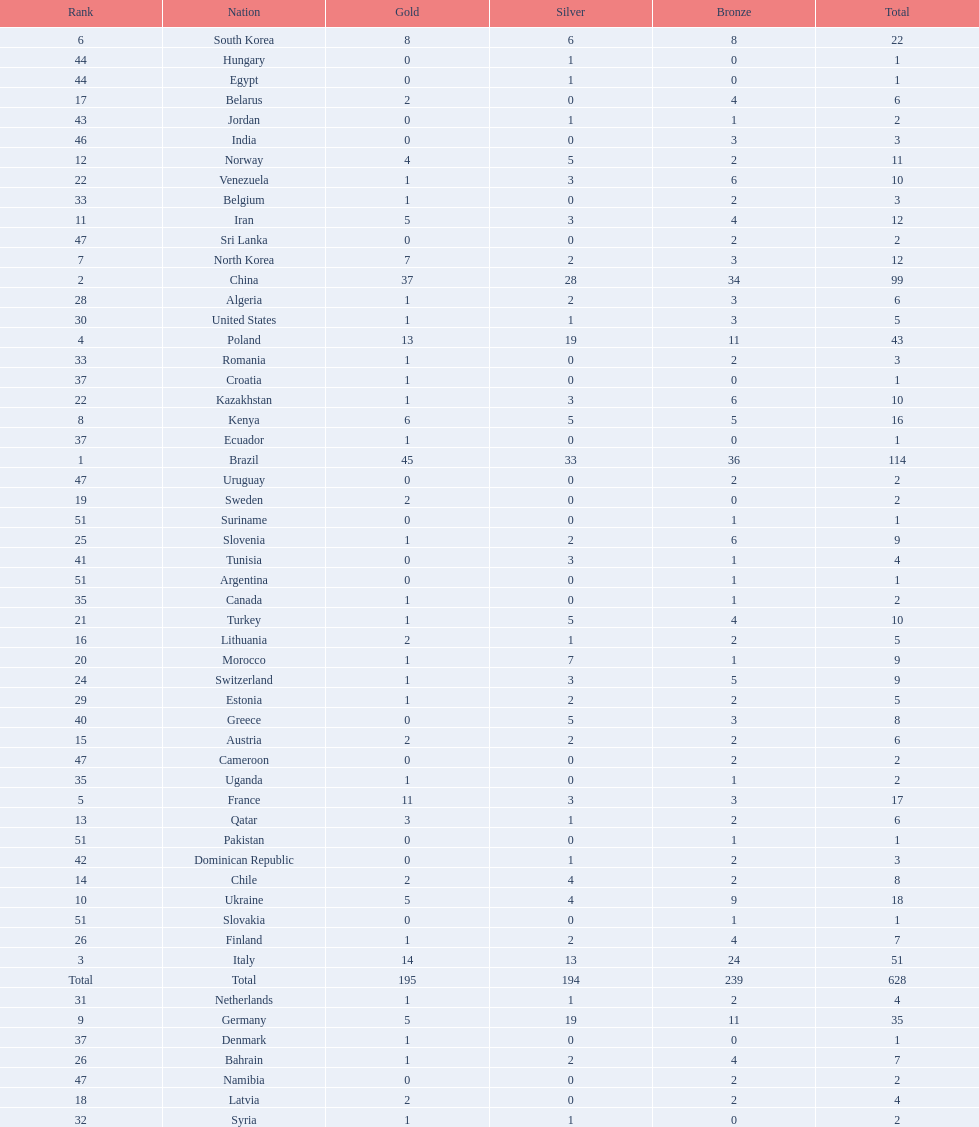How many total medals did norway win? 11. 